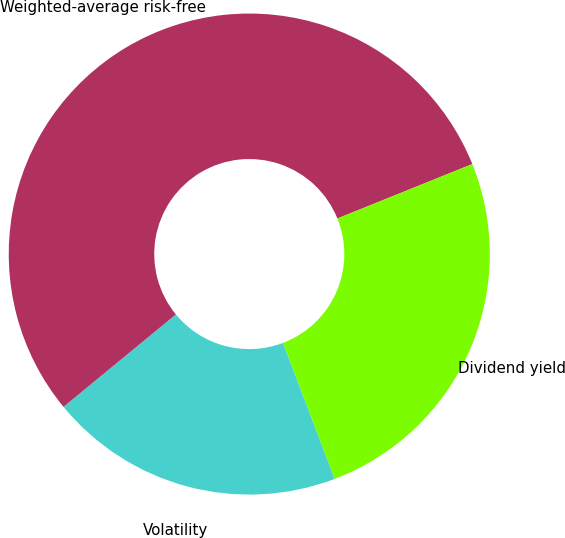Convert chart to OTSL. <chart><loc_0><loc_0><loc_500><loc_500><pie_chart><fcel>Volatility<fcel>Weighted-average risk-free<fcel>Dividend yield<nl><fcel>19.83%<fcel>54.85%<fcel>25.32%<nl></chart> 